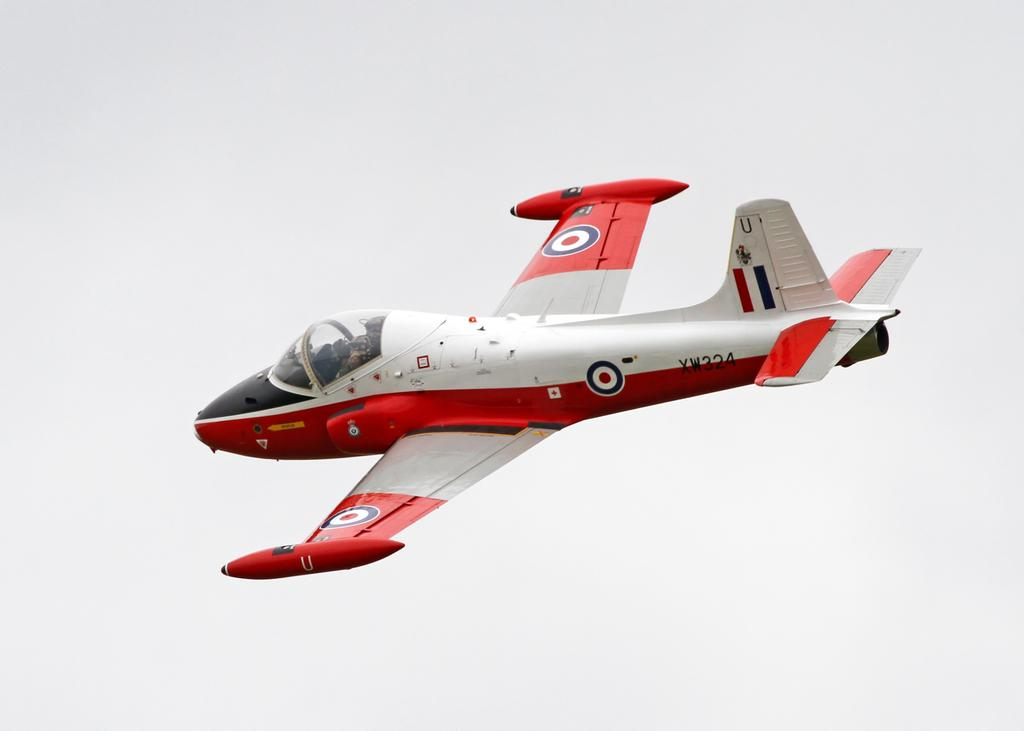Provide a one-sentence caption for the provided image. A red and white plane is flying in the air with XW324 on the tail. 